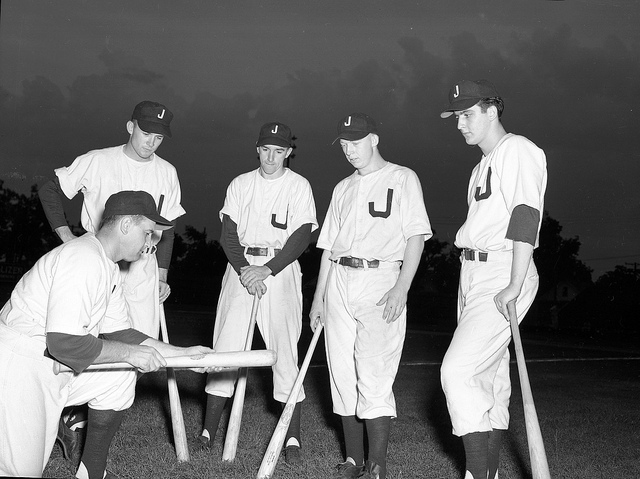Read and extract the text from this image. J J J J J J J J 